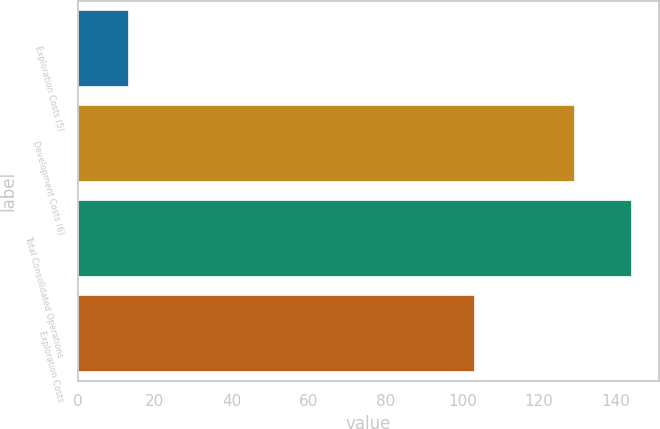Convert chart to OTSL. <chart><loc_0><loc_0><loc_500><loc_500><bar_chart><fcel>Exploration Costs (5)<fcel>Development Costs (6)<fcel>Total Consolidated Operations<fcel>Exploration Costs<nl><fcel>13<fcel>129<fcel>144<fcel>103<nl></chart> 